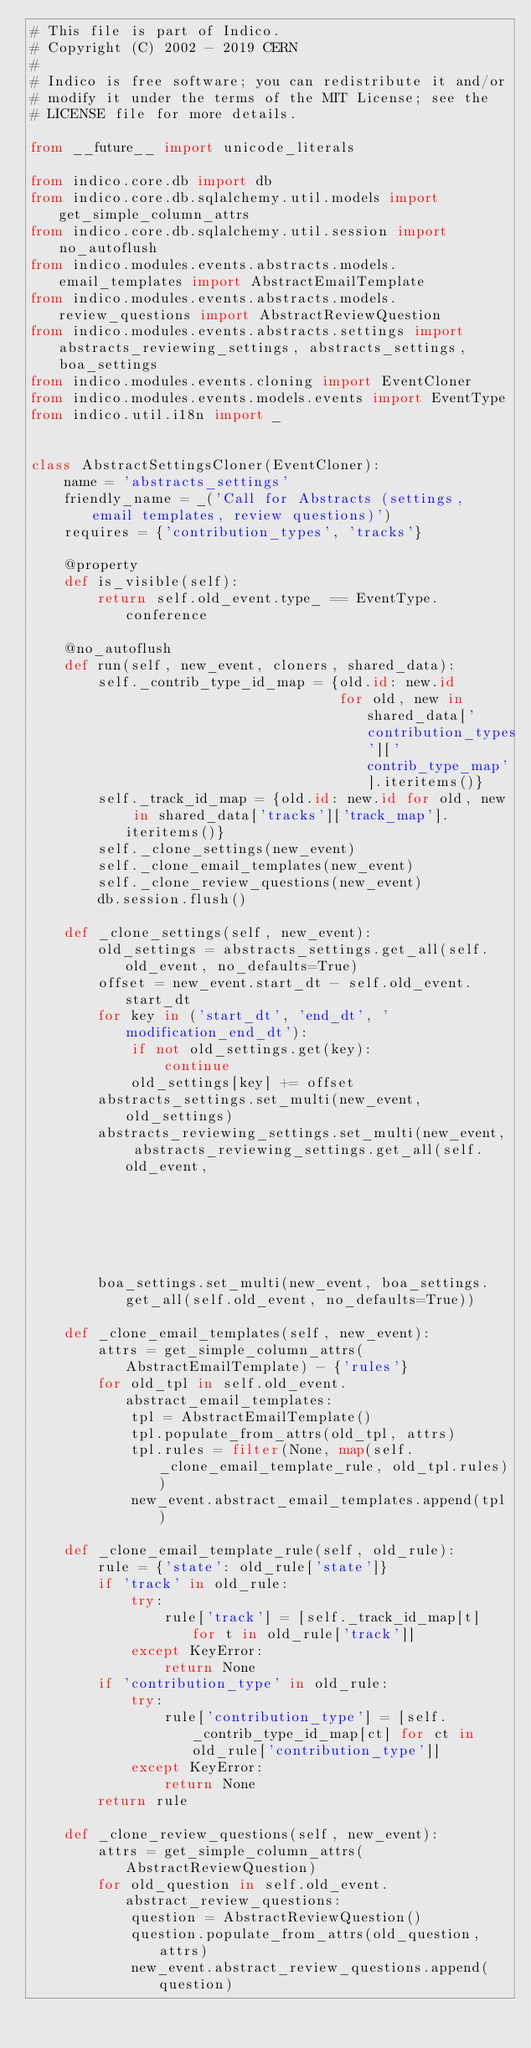<code> <loc_0><loc_0><loc_500><loc_500><_Python_># This file is part of Indico.
# Copyright (C) 2002 - 2019 CERN
#
# Indico is free software; you can redistribute it and/or
# modify it under the terms of the MIT License; see the
# LICENSE file for more details.

from __future__ import unicode_literals

from indico.core.db import db
from indico.core.db.sqlalchemy.util.models import get_simple_column_attrs
from indico.core.db.sqlalchemy.util.session import no_autoflush
from indico.modules.events.abstracts.models.email_templates import AbstractEmailTemplate
from indico.modules.events.abstracts.models.review_questions import AbstractReviewQuestion
from indico.modules.events.abstracts.settings import abstracts_reviewing_settings, abstracts_settings, boa_settings
from indico.modules.events.cloning import EventCloner
from indico.modules.events.models.events import EventType
from indico.util.i18n import _


class AbstractSettingsCloner(EventCloner):
    name = 'abstracts_settings'
    friendly_name = _('Call for Abstracts (settings, email templates, review questions)')
    requires = {'contribution_types', 'tracks'}

    @property
    def is_visible(self):
        return self.old_event.type_ == EventType.conference

    @no_autoflush
    def run(self, new_event, cloners, shared_data):
        self._contrib_type_id_map = {old.id: new.id
                                     for old, new in shared_data['contribution_types']['contrib_type_map'].iteritems()}
        self._track_id_map = {old.id: new.id for old, new in shared_data['tracks']['track_map'].iteritems()}
        self._clone_settings(new_event)
        self._clone_email_templates(new_event)
        self._clone_review_questions(new_event)
        db.session.flush()

    def _clone_settings(self, new_event):
        old_settings = abstracts_settings.get_all(self.old_event, no_defaults=True)
        offset = new_event.start_dt - self.old_event.start_dt
        for key in ('start_dt', 'end_dt', 'modification_end_dt'):
            if not old_settings.get(key):
                continue
            old_settings[key] += offset
        abstracts_settings.set_multi(new_event, old_settings)
        abstracts_reviewing_settings.set_multi(new_event, abstracts_reviewing_settings.get_all(self.old_event,
                                                                                               no_defaults=True))
        boa_settings.set_multi(new_event, boa_settings.get_all(self.old_event, no_defaults=True))

    def _clone_email_templates(self, new_event):
        attrs = get_simple_column_attrs(AbstractEmailTemplate) - {'rules'}
        for old_tpl in self.old_event.abstract_email_templates:
            tpl = AbstractEmailTemplate()
            tpl.populate_from_attrs(old_tpl, attrs)
            tpl.rules = filter(None, map(self._clone_email_template_rule, old_tpl.rules))
            new_event.abstract_email_templates.append(tpl)

    def _clone_email_template_rule(self, old_rule):
        rule = {'state': old_rule['state']}
        if 'track' in old_rule:
            try:
                rule['track'] = [self._track_id_map[t] for t in old_rule['track']]
            except KeyError:
                return None
        if 'contribution_type' in old_rule:
            try:
                rule['contribution_type'] = [self._contrib_type_id_map[ct] for ct in old_rule['contribution_type']]
            except KeyError:
                return None
        return rule

    def _clone_review_questions(self, new_event):
        attrs = get_simple_column_attrs(AbstractReviewQuestion)
        for old_question in self.old_event.abstract_review_questions:
            question = AbstractReviewQuestion()
            question.populate_from_attrs(old_question, attrs)
            new_event.abstract_review_questions.append(question)
</code> 